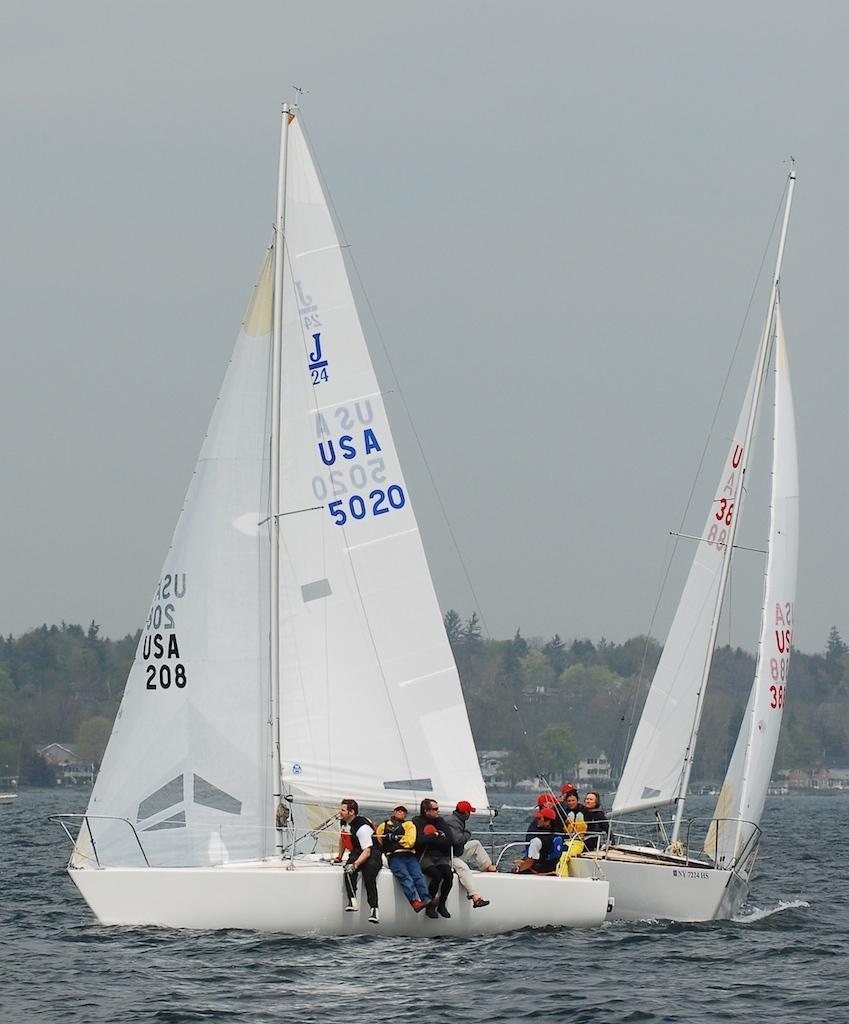Describe this image in one or two sentences. In this image I can see water in the front and on it I can see few boats. I can also see few people on these boats. In the background I can see number of trees, few buildings and on these boats I can see something is written. 